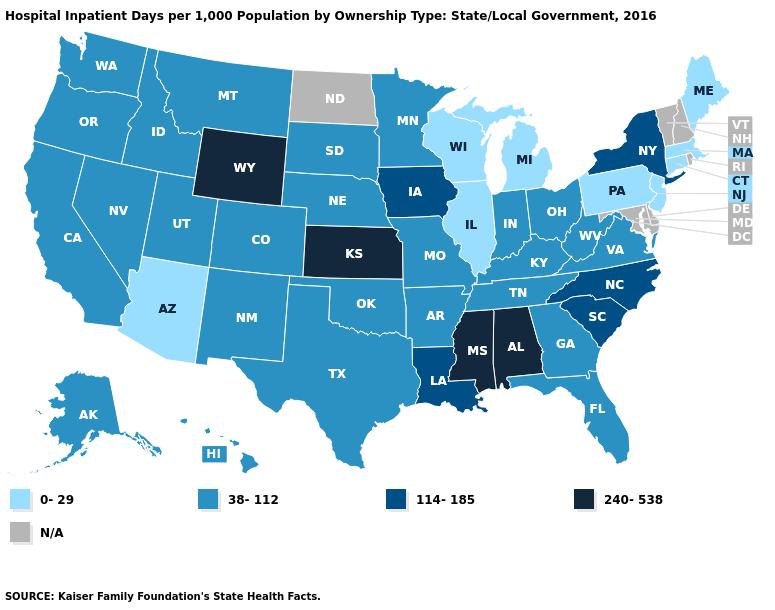What is the value of New Mexico?
Keep it brief. 38-112. Name the states that have a value in the range N/A?
Short answer required. Delaware, Maryland, New Hampshire, North Dakota, Rhode Island, Vermont. Name the states that have a value in the range 240-538?
Concise answer only. Alabama, Kansas, Mississippi, Wyoming. Name the states that have a value in the range N/A?
Give a very brief answer. Delaware, Maryland, New Hampshire, North Dakota, Rhode Island, Vermont. Name the states that have a value in the range 240-538?
Concise answer only. Alabama, Kansas, Mississippi, Wyoming. Which states hav the highest value in the West?
Concise answer only. Wyoming. Which states have the lowest value in the MidWest?
Concise answer only. Illinois, Michigan, Wisconsin. Among the states that border Ohio , does West Virginia have the highest value?
Answer briefly. Yes. What is the lowest value in the USA?
Concise answer only. 0-29. What is the value of Missouri?
Concise answer only. 38-112. What is the value of Idaho?
Quick response, please. 38-112. Which states have the lowest value in the USA?
Quick response, please. Arizona, Connecticut, Illinois, Maine, Massachusetts, Michigan, New Jersey, Pennsylvania, Wisconsin. Name the states that have a value in the range 240-538?
Be succinct. Alabama, Kansas, Mississippi, Wyoming. What is the highest value in states that border North Carolina?
Keep it brief. 114-185. 